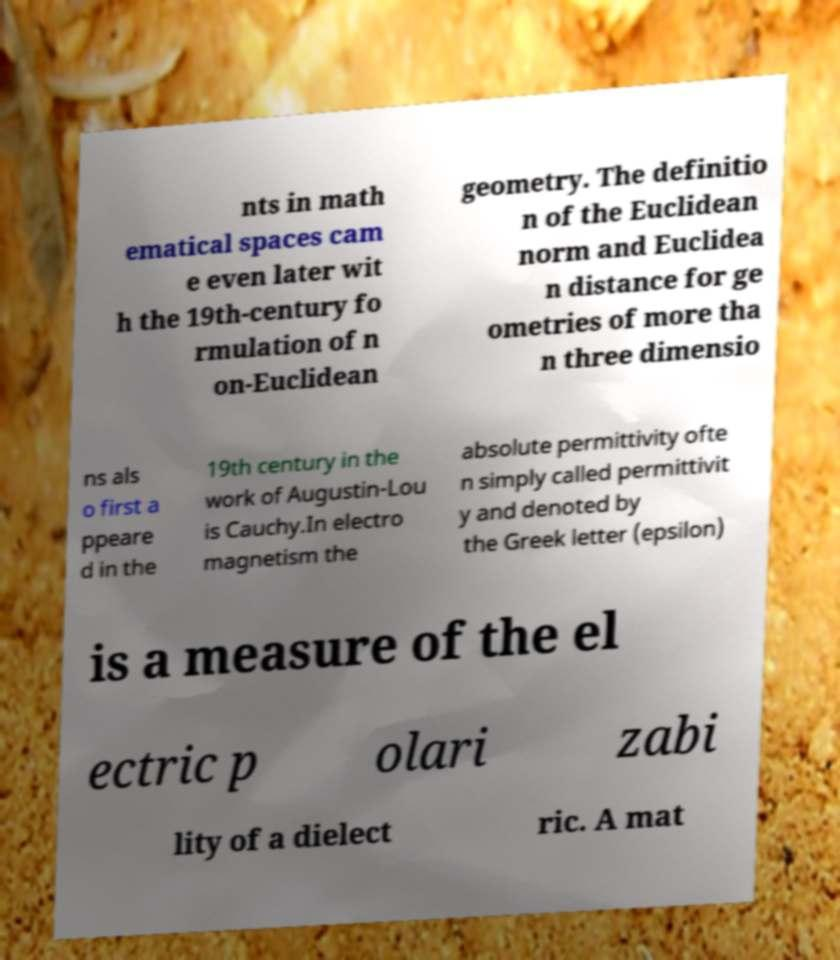Please read and relay the text visible in this image. What does it say? nts in math ematical spaces cam e even later wit h the 19th-century fo rmulation of n on-Euclidean geometry. The definitio n of the Euclidean norm and Euclidea n distance for ge ometries of more tha n three dimensio ns als o first a ppeare d in the 19th century in the work of Augustin-Lou is Cauchy.In electro magnetism the absolute permittivity ofte n simply called permittivit y and denoted by the Greek letter (epsilon) is a measure of the el ectric p olari zabi lity of a dielect ric. A mat 